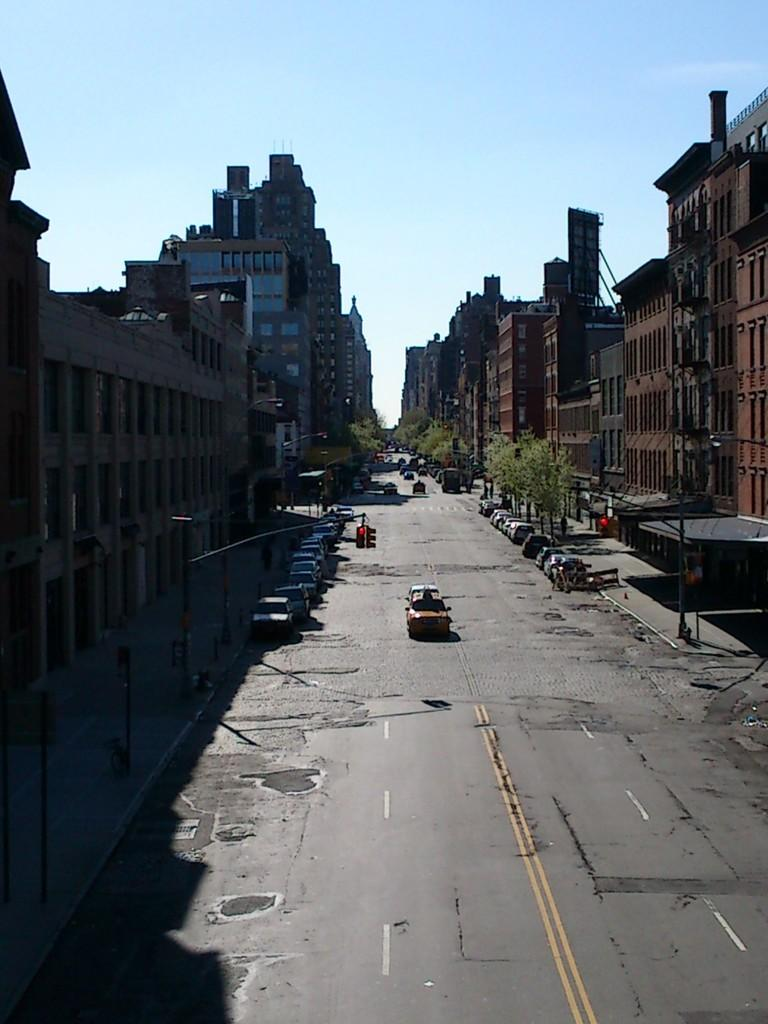What is the main feature of the image? There is a road in the image. What can be seen on either side of the road? Cars are present on either side of the road. What is located behind the road? There are buildings behind the road. What is in front of the buildings? Trees are in front of the buildings. What part of the natural environment is visible in the image? The sky is visible above the scene. What type of veil can be seen covering the trees in the image? There is no veil present in the image; the trees are not covered. What is the size of the cars in the image? The size of the cars cannot be determined from the image alone, as there is no reference for scale. 